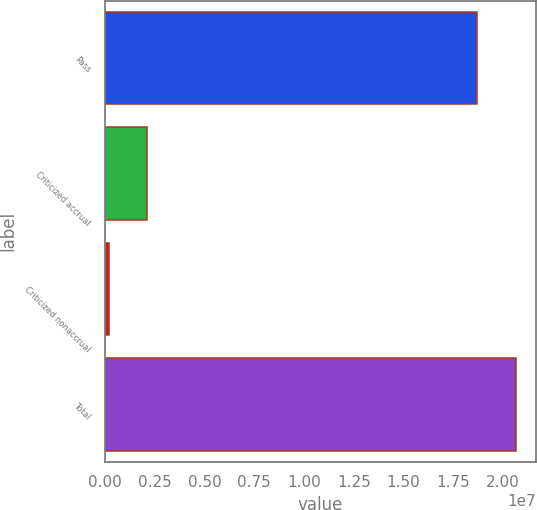Convert chart. <chart><loc_0><loc_0><loc_500><loc_500><bar_chart><fcel>Pass<fcel>Criticized accrual<fcel>Criticized nonaccrual<fcel>Total<nl><fcel>1.86954e+07<fcel>2.10583e+06<fcel>177445<fcel>2.06238e+07<nl></chart> 